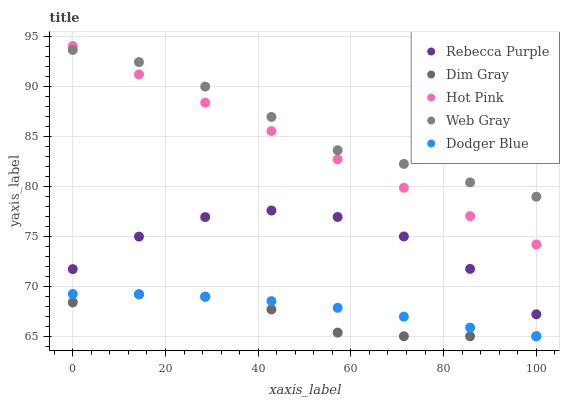Does Dim Gray have the minimum area under the curve?
Answer yes or no. Yes. Does Web Gray have the maximum area under the curve?
Answer yes or no. Yes. Does Web Gray have the minimum area under the curve?
Answer yes or no. No. Does Dim Gray have the maximum area under the curve?
Answer yes or no. No. Is Hot Pink the smoothest?
Answer yes or no. Yes. Is Rebecca Purple the roughest?
Answer yes or no. Yes. Is Dim Gray the smoothest?
Answer yes or no. No. Is Dim Gray the roughest?
Answer yes or no. No. Does Dodger Blue have the lowest value?
Answer yes or no. Yes. Does Web Gray have the lowest value?
Answer yes or no. No. Does Hot Pink have the highest value?
Answer yes or no. Yes. Does Web Gray have the highest value?
Answer yes or no. No. Is Dodger Blue less than Web Gray?
Answer yes or no. Yes. Is Web Gray greater than Dodger Blue?
Answer yes or no. Yes. Does Dodger Blue intersect Dim Gray?
Answer yes or no. Yes. Is Dodger Blue less than Dim Gray?
Answer yes or no. No. Is Dodger Blue greater than Dim Gray?
Answer yes or no. No. Does Dodger Blue intersect Web Gray?
Answer yes or no. No. 